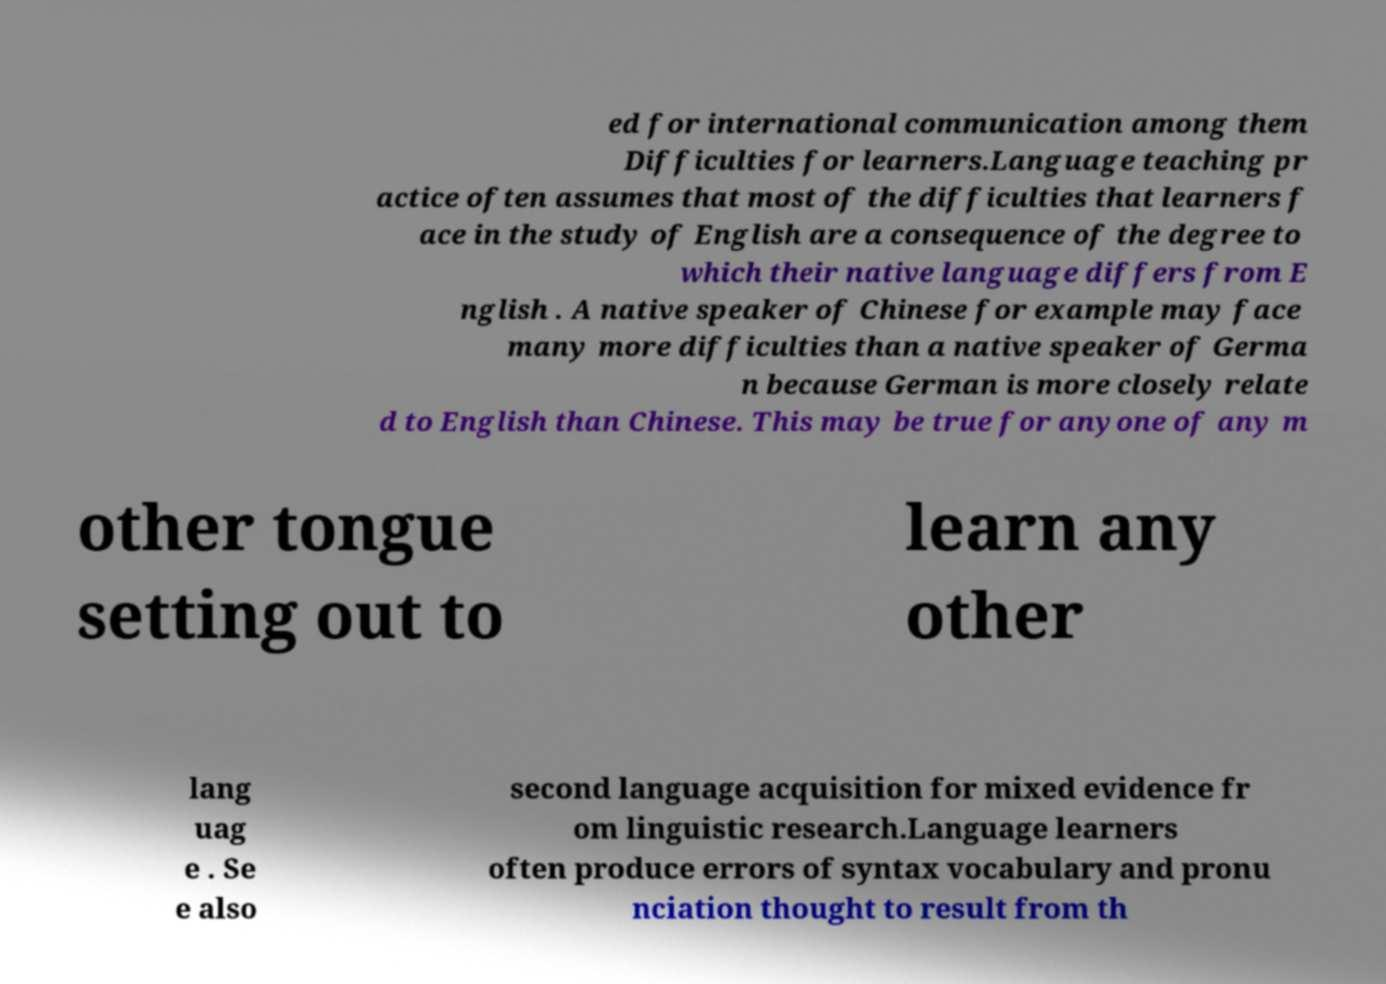Please read and relay the text visible in this image. What does it say? ed for international communication among them Difficulties for learners.Language teaching pr actice often assumes that most of the difficulties that learners f ace in the study of English are a consequence of the degree to which their native language differs from E nglish . A native speaker of Chinese for example may face many more difficulties than a native speaker of Germa n because German is more closely relate d to English than Chinese. This may be true for anyone of any m other tongue setting out to learn any other lang uag e . Se e also second language acquisition for mixed evidence fr om linguistic research.Language learners often produce errors of syntax vocabulary and pronu nciation thought to result from th 